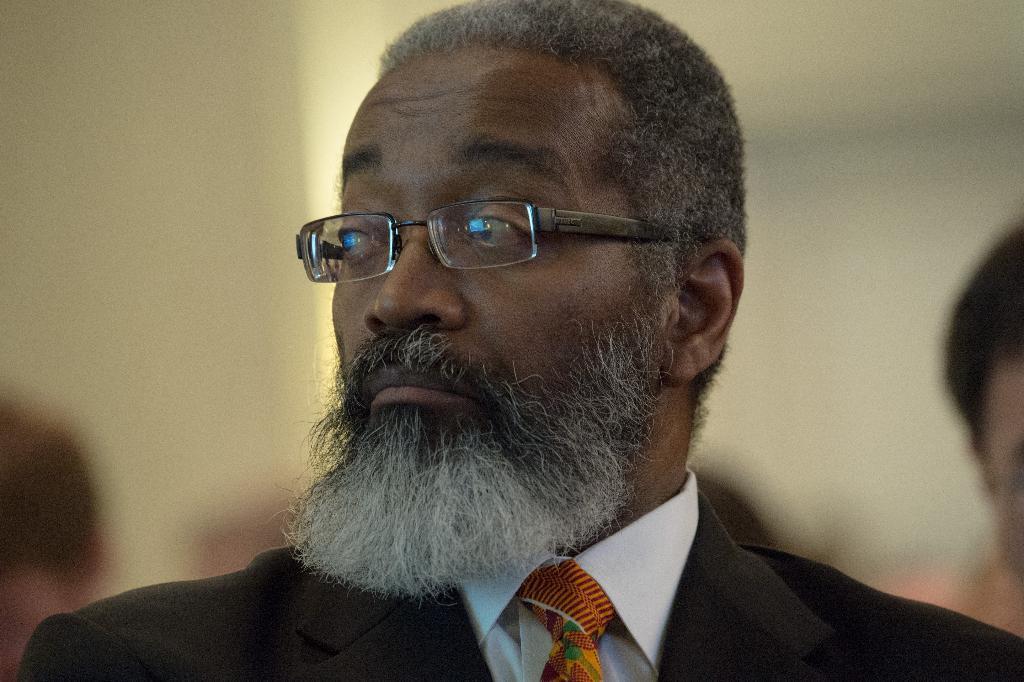Can you describe this image briefly? There is a man wearing specs, black coat and a tie. In the background there is sky. 